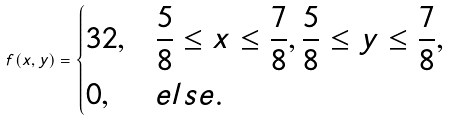Convert formula to latex. <formula><loc_0><loc_0><loc_500><loc_500>f ( x , y ) = \begin{dcases} 3 2 , & \frac { 5 } { 8 } \leq x \leq \frac { 7 } { 8 } , \frac { 5 } { 8 } \leq y \leq \frac { 7 } { 8 } , \\ 0 , & e l s e . \\ \end{dcases}</formula> 